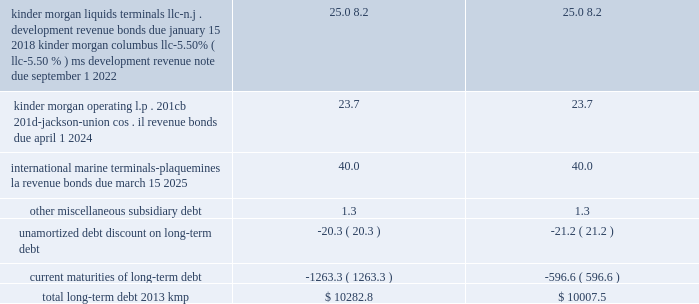Item 15 .
Exhibits , financial statement schedules .
( continued ) kinder morgan , inc .
Form 10-k .
____________ ( a ) as a result of the implementation of asu 2009-17 , effective january 1 , 2010 , we ( i ) include the transactions and balances of our business trust , k n capital trust i and k n capital trust iii , in our consolidated financial statements and ( ii ) no longer include our junior subordinated deferrable interest debentures issued to the capital trusts ( see note 18 201crecent accounting pronouncements 201d ) .
( b ) kmp issued its $ 500 million in principal amount of 9.00% ( 9.00 % ) senior notes due february 1 , 2019 in december 2008 .
Each holder of the notes has the right to require kmp to repurchase all or a portion of the notes owned by such holder on february 1 , 2012 at a purchase price equal to 100% ( 100 % ) of the principal amount of the notes tendered by the holder plus accrued and unpaid interest to , but excluding , the repurchase date .
On and after february 1 , 2012 , interest will cease to accrue on the notes tendered for repayment .
A holder 2019s exercise of the repurchase option is irrevocable .
Kinder morgan kansas , inc .
The 2028 and 2098 debentures and the 2012 and 2015 senior notes are redeemable in whole or in part , at kinder morgan kansas , inc . 2019s option at any time , at redemption prices defined in the associated prospectus supplements .
The 2027 debentures are redeemable in whole or in part , at kinder morgan kansas , inc . 2019s option after november 1 , 2004 at redemption prices defined in the associated prospectus supplements .
On september 2 , 2010 , kinder morgan kansas , inc .
Paid the remaining $ 1.1 million principal balance outstanding on kinder morgan kansas , inc . 2019s 6.50% ( 6.50 % ) series debentures , due 2013 .
Kinder morgan finance company , llc on december 20 , 2010 , kinder morgan finance company , llc , a wholly owned subsidiary of kinder morgan kansas , inc. , completed a public offering of senior notes .
It issued a total of $ 750 million in principal amount of 6.00% ( 6.00 % ) senior notes due january 15 , 2018 .
Net proceeds received from the issuance of the notes , after underwriting discounts and commissions , were $ 744.2 million , which were used to retire the principal amount of the 5.35% ( 5.35 % ) senior notes that matured on january 5 , 2011 .
The 2011 , 2016 , 2018 and 2036 senior notes issued by kinder morgan finance company , llc are redeemable in whole or in part , at kinder morgan kansas , inc . 2019s option at any time , at redemption prices defined in the associated prospectus supplements .
Each series of these notes is fully and unconditionally guaranteed by kinder morgan kansas , inc .
On a senior unsecured basis as to principal , interest and any additional amounts required to be paid as a result of any withholding or deduction for canadian taxes .
Capital trust securities kinder morgan kansas , inc . 2019s business trusts , k n capital trust i and k n capital trust iii , are obligated for $ 12.7 million of 8.56% ( 8.56 % ) capital trust securities maturing on april 15 , 2027 and $ 14.4 million of 7.63% ( 7.63 % ) capital trust securities maturing on april 15 , 2028 , respectively , which it guarantees .
The 2028 securities are redeemable in whole or in part , at kinder morgan kansas , inc . 2019s option at any time , at redemption prices as defined in the associated prospectus .
The 2027 securities are redeemable in whole or in part at kinder morgan kansas , inc . 2019s option and at any time in certain limited circumstances upon the occurrence of certain events and at prices , all defined in the associated prospectus supplements .
Upon redemption by kinder morgan kansas , inc .
Or at maturity of the junior subordinated deferrable interest debentures , it must use the proceeds to make redemptions of the capital trust securities on a pro rata basis. .
What is the value of current maturities of long-term debt as a percent of total long-term debt for the first column? 
Rationale: it looks like this might not be the full figure as it says ( continued ) and is missing labels of categories .
Computations: ((1263.3 * const_m1) * 100%)
Answer: -1263.3. Item 15 .
Exhibits , financial statement schedules .
( continued ) kinder morgan , inc .
Form 10-k .
____________ ( a ) as a result of the implementation of asu 2009-17 , effective january 1 , 2010 , we ( i ) include the transactions and balances of our business trust , k n capital trust i and k n capital trust iii , in our consolidated financial statements and ( ii ) no longer include our junior subordinated deferrable interest debentures issued to the capital trusts ( see note 18 201crecent accounting pronouncements 201d ) .
( b ) kmp issued its $ 500 million in principal amount of 9.00% ( 9.00 % ) senior notes due february 1 , 2019 in december 2008 .
Each holder of the notes has the right to require kmp to repurchase all or a portion of the notes owned by such holder on february 1 , 2012 at a purchase price equal to 100% ( 100 % ) of the principal amount of the notes tendered by the holder plus accrued and unpaid interest to , but excluding , the repurchase date .
On and after february 1 , 2012 , interest will cease to accrue on the notes tendered for repayment .
A holder 2019s exercise of the repurchase option is irrevocable .
Kinder morgan kansas , inc .
The 2028 and 2098 debentures and the 2012 and 2015 senior notes are redeemable in whole or in part , at kinder morgan kansas , inc . 2019s option at any time , at redemption prices defined in the associated prospectus supplements .
The 2027 debentures are redeemable in whole or in part , at kinder morgan kansas , inc . 2019s option after november 1 , 2004 at redemption prices defined in the associated prospectus supplements .
On september 2 , 2010 , kinder morgan kansas , inc .
Paid the remaining $ 1.1 million principal balance outstanding on kinder morgan kansas , inc . 2019s 6.50% ( 6.50 % ) series debentures , due 2013 .
Kinder morgan finance company , llc on december 20 , 2010 , kinder morgan finance company , llc , a wholly owned subsidiary of kinder morgan kansas , inc. , completed a public offering of senior notes .
It issued a total of $ 750 million in principal amount of 6.00% ( 6.00 % ) senior notes due january 15 , 2018 .
Net proceeds received from the issuance of the notes , after underwriting discounts and commissions , were $ 744.2 million , which were used to retire the principal amount of the 5.35% ( 5.35 % ) senior notes that matured on january 5 , 2011 .
The 2011 , 2016 , 2018 and 2036 senior notes issued by kinder morgan finance company , llc are redeemable in whole or in part , at kinder morgan kansas , inc . 2019s option at any time , at redemption prices defined in the associated prospectus supplements .
Each series of these notes is fully and unconditionally guaranteed by kinder morgan kansas , inc .
On a senior unsecured basis as to principal , interest and any additional amounts required to be paid as a result of any withholding or deduction for canadian taxes .
Capital trust securities kinder morgan kansas , inc . 2019s business trusts , k n capital trust i and k n capital trust iii , are obligated for $ 12.7 million of 8.56% ( 8.56 % ) capital trust securities maturing on april 15 , 2027 and $ 14.4 million of 7.63% ( 7.63 % ) capital trust securities maturing on april 15 , 2028 , respectively , which it guarantees .
The 2028 securities are redeemable in whole or in part , at kinder morgan kansas , inc . 2019s option at any time , at redemption prices as defined in the associated prospectus .
The 2027 securities are redeemable in whole or in part at kinder morgan kansas , inc . 2019s option and at any time in certain limited circumstances upon the occurrence of certain events and at prices , all defined in the associated prospectus supplements .
Upon redemption by kinder morgan kansas , inc .
Or at maturity of the junior subordinated deferrable interest debentures , it must use the proceeds to make redemptions of the capital trust securities on a pro rata basis. .
What percent of total long-term debt 2013 kmp after the implementation of asu 2009-17 is current maturities? 
Computations: (1263.3 / (10282.8 + 1263.3))
Answer: 0.10941. 